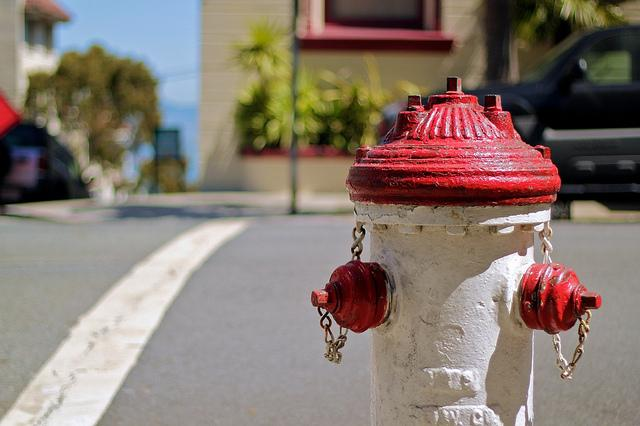What does the line near the hydrant signify? crosswalk 